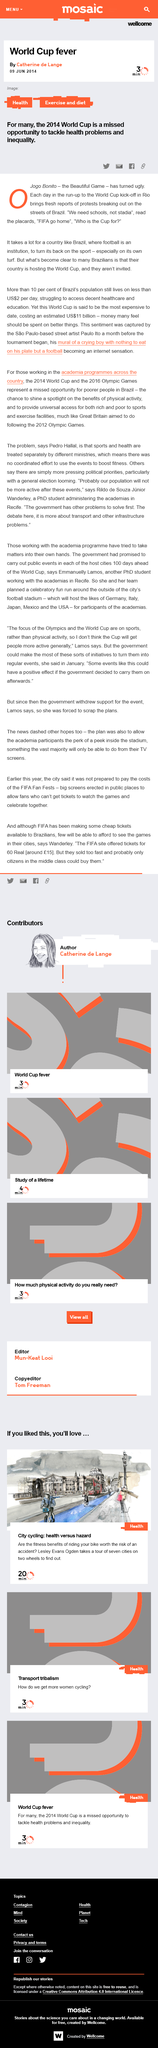Mention a couple of crucial points in this snapshot. The post was published on the 9th June 2014. Catherine de Lange is the author of the post titled 'World Cup fever'. The daily budget of more than 10% of the Brazilian population is less than $2, which is a small amount compared to the daily expenses of the majority of individuals in Brazil. 